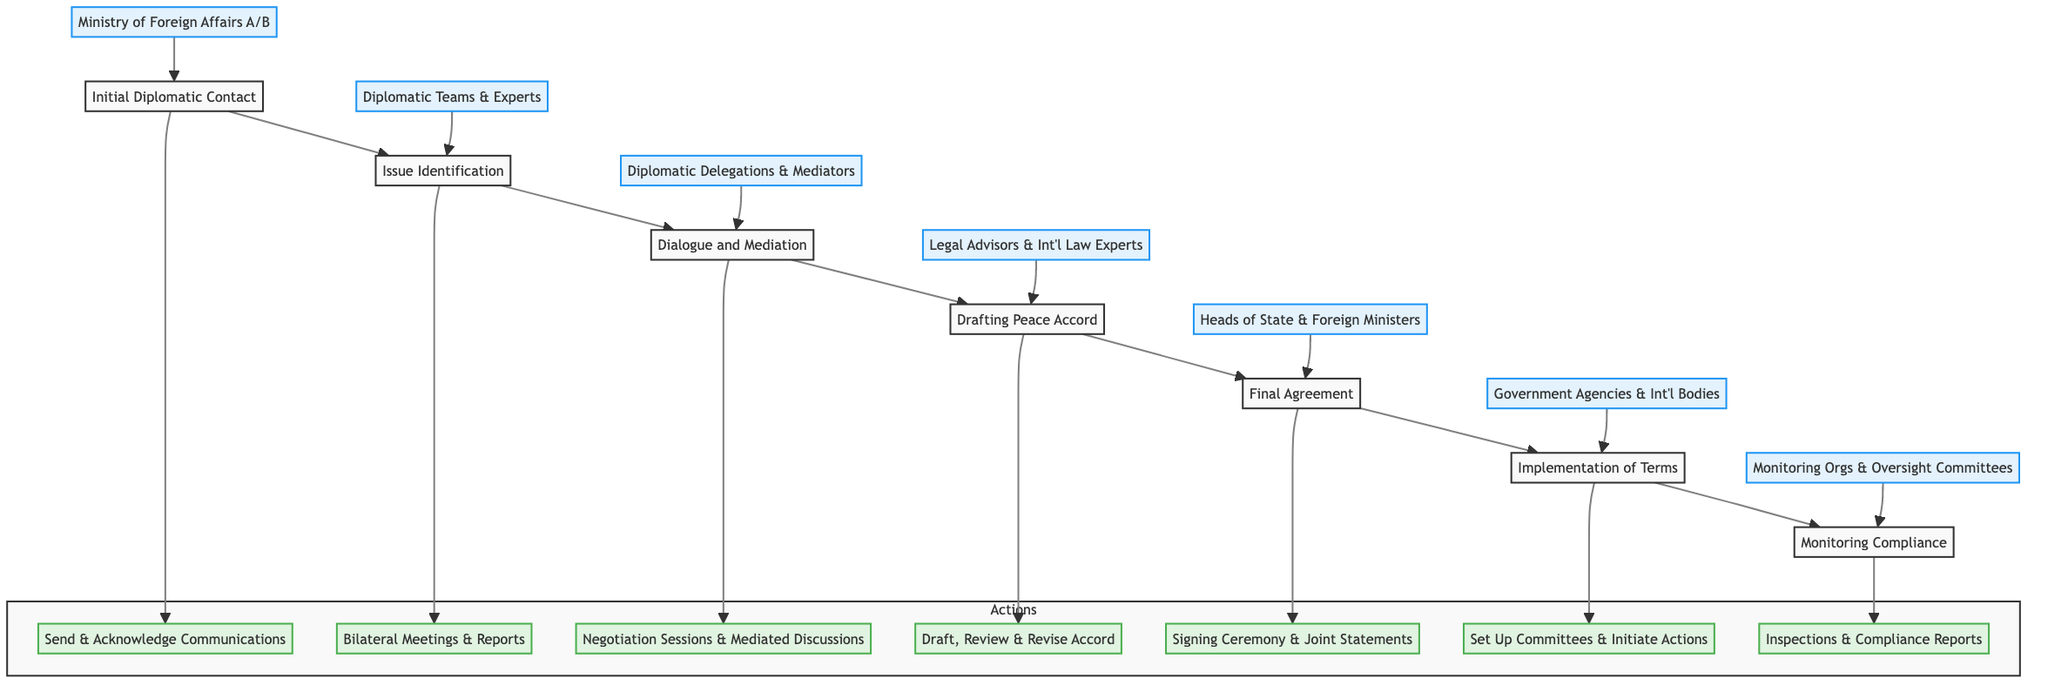What is the first step in the protocol? The first step in the conflict resolution protocol is labeled "Initial Diplomatic Contact." This is the starting point of the flowchart and indicates the beginning of the process.
Answer: Initial Diplomatic Contact How many main steps are in the flowchart? By counting the labeled nodes in the flowchart, we see there are seven main steps listed from Initial Diplomatic Contact to Monitoring Compliance.
Answer: Seven Which entities are involved in the "Drafting Peace Accord" step? In the "Drafting Peace Accord" step, the entities involved are "Legal Advisors from both countries" and "International Law Experts," which are clearly stated under that node in the diagram.
Answer: Legal Advisors from both countries, International Law Experts What action is associated with the "Issue Identification" step? The action associated with "Issue Identification" is "Conduct bilateral meetings" and "Prepare and exchange reports on conflict issues," as documented in the actions section below the "Issue Identification" node.
Answer: Conduct bilateral meetings, Prepare and exchange reports on conflict issues Which step follows "Dialogue and Mediation"? The step that follows "Dialogue and Mediation" in the sequence of the diagram is "Drafting Peace Accord." By tracing the arrows in the flowchart, one can see the progression from one step to the next.
Answer: Drafting Peace Accord What is the role of the "Independent Monitoring Organizations" in the protocol? The "Independent Monitoring Organizations" play a role in the "Monitoring Compliance" step, where their actions include conducting regular inspections and issuing compliance reports, as specified in the flowchart.
Answer: Conducting regular inspections, issuing compliance reports How are the actions in the protocol structured? The actions in the protocol are organized in a subgraph labeled "Actions," which clearly outlines specific processes tied to each of the steps in the flowchart, showing the sequence and relationship of actions to the main steps.
Answer: Subgraph labeled "Actions" What is the significance of the "Final Agreement" step? The "Final Agreement" step represents a critical point where the peace accord is formalized with signatures, which signifies the culmination of the negotiation process, as indicated by the associated entities and actions described in the diagram.
Answer: Finalization of the peace accord with signatures 